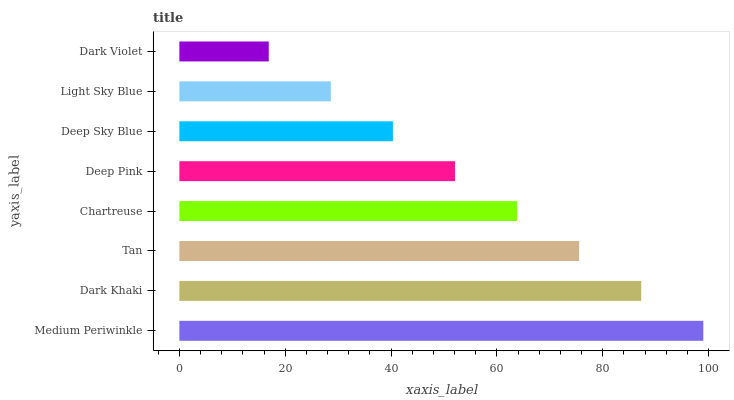Is Dark Violet the minimum?
Answer yes or no. Yes. Is Medium Periwinkle the maximum?
Answer yes or no. Yes. Is Dark Khaki the minimum?
Answer yes or no. No. Is Dark Khaki the maximum?
Answer yes or no. No. Is Medium Periwinkle greater than Dark Khaki?
Answer yes or no. Yes. Is Dark Khaki less than Medium Periwinkle?
Answer yes or no. Yes. Is Dark Khaki greater than Medium Periwinkle?
Answer yes or no. No. Is Medium Periwinkle less than Dark Khaki?
Answer yes or no. No. Is Chartreuse the high median?
Answer yes or no. Yes. Is Deep Pink the low median?
Answer yes or no. Yes. Is Deep Pink the high median?
Answer yes or no. No. Is Tan the low median?
Answer yes or no. No. 